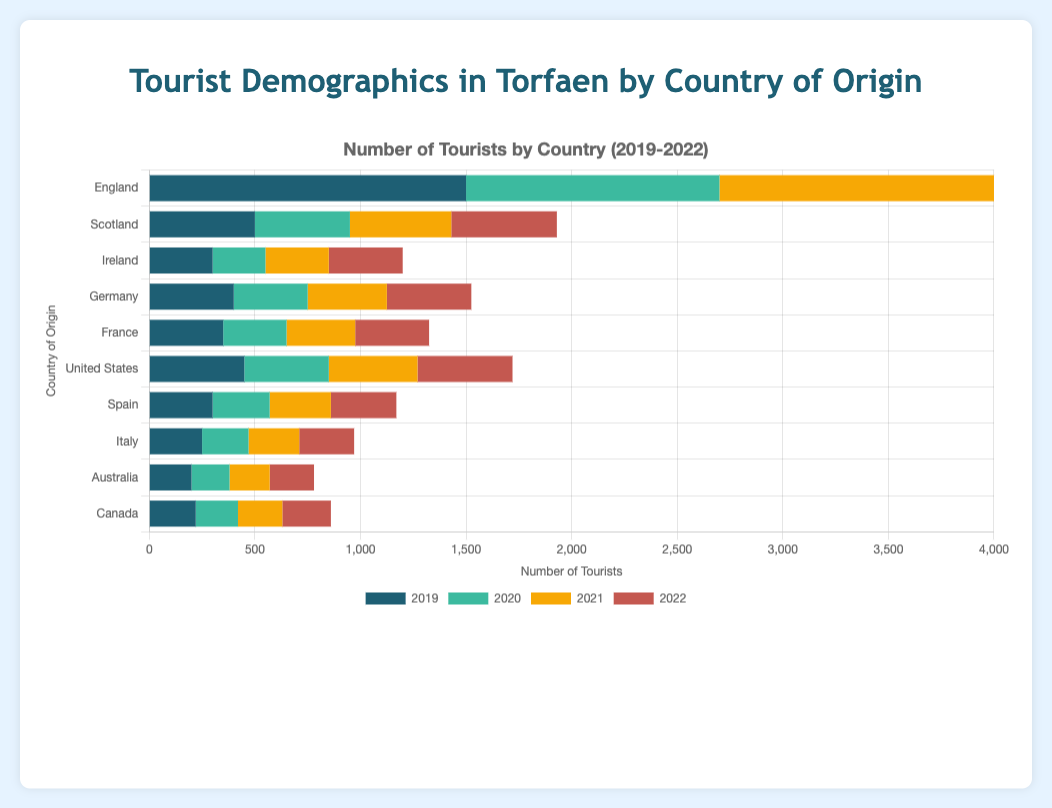Which country had the highest number of tourists in 2019? By looking at the figure, observe that the bar labeled "England" for 2019 is the longest, indicating it had the highest number of tourists.
Answer: England How did the number of tourists from Ireland change from 2020 to 2022? In 2020, Ireland had 250 tourists, and by 2022, it had 350 tourists. Subtract 250 from 350 to find the change: 350 - 250 = 100.
Answer: Increased by 100 Which country saw a decrease in tourists from 2019 to 2020? England had 1500 tourists in 2019 and 1200 in 2020, showing a decrease. Scotland, Ireland, Germany, France, Spain, Italy, Australia, and Canada also saw decreases in this period.
Answer: Multiple countries (including England) Compare the number of tourists from the United States to Germany in 2021. Which had more? The United States had 420 tourists, while Germany had 375 in 2021. Comparing these, the United States had more.
Answer: United States What was the total number of tourists from all countries in 2022? For 2022, sum the tourist numbers: 1400 (England) + 500 (Scotland) + 350 (Ireland) + 400 (Germany) + 350 (France) + 450 (United States) + 310 (Spain) + 260 (Italy) + 210 (Australia) + 230 (Canada) = 4460
Answer: 4460 What color represents the data for 2019 in the chart? In the chart, the bar for 2019 is colored in a distinct shade. This shade is blue.
Answer: Blue How did the number of tourists from France from 2019 to 2022 change? In 2019, there were 350 tourists, and there were also 350 in 2022, indicating no change from 2019 to 2022.
Answer: No change What’s the average number of tourists from Germany from 2019 to 2022? Add the tourist numbers for Germany across the years and divide by 4: (400 + 350 + 375 + 400) / 4 = 1525 / 4 = 381.25
Answer: 381.25 Which year saw the highest total number of tourists from all countries combined? Calculate the total tourists for each year: 2019: 4470, 2020: 3770, 2021: 3830, 2022: 4460. 2019 has the highest total.
Answer: 2019 Between Spain and Canada, which country had more tourists in 2020? Spain had 270 and Canada had 200 tourists in 2020. Comparing these, Spain had more.
Answer: Spain 